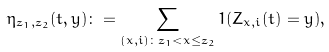Convert formula to latex. <formula><loc_0><loc_0><loc_500><loc_500>\eta _ { z _ { 1 } , z _ { 2 } } ( t , y ) \colon = \sum _ { ( x , i ) \colon z _ { 1 } < x \leq z _ { 2 } } 1 ( Z _ { x , i } ( t ) = y ) ,</formula> 